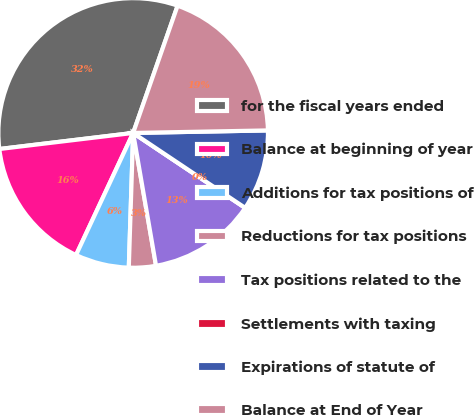<chart> <loc_0><loc_0><loc_500><loc_500><pie_chart><fcel>for the fiscal years ended<fcel>Balance at beginning of year<fcel>Additions for tax positions of<fcel>Reductions for tax positions<fcel>Tax positions related to the<fcel>Settlements with taxing<fcel>Expirations of statute of<fcel>Balance at End of Year<nl><fcel>32.25%<fcel>16.13%<fcel>6.45%<fcel>3.23%<fcel>12.9%<fcel>0.0%<fcel>9.68%<fcel>19.35%<nl></chart> 